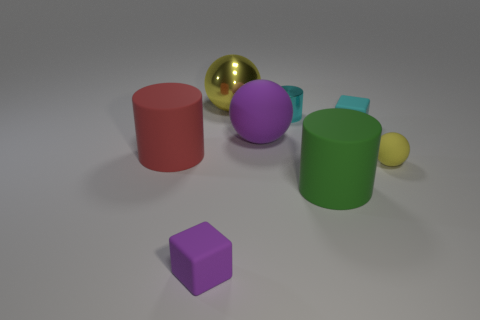Subtract all yellow balls. How many were subtracted if there are1yellow balls left? 1 Add 1 cyan metal blocks. How many objects exist? 9 Subtract all balls. How many objects are left? 5 Subtract all large yellow objects. Subtract all tiny cyan blocks. How many objects are left? 6 Add 6 metal balls. How many metal balls are left? 7 Add 2 blue rubber blocks. How many blue rubber blocks exist? 2 Subtract 0 green blocks. How many objects are left? 8 